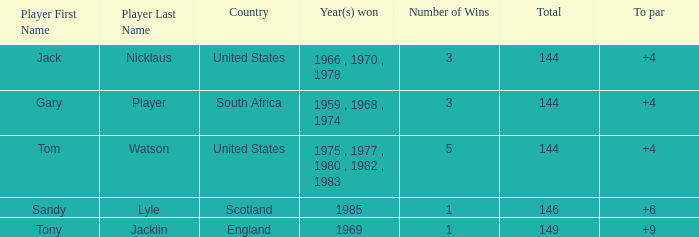What was England's total? 149.0. 